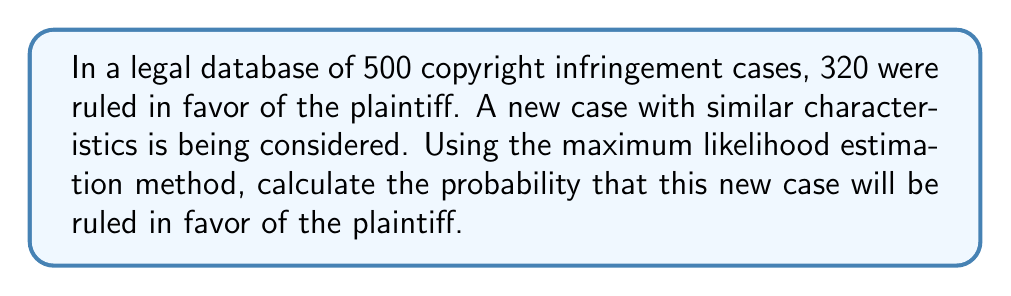Solve this math problem. To solve this inverse problem, we'll use the maximum likelihood estimation (MLE) method to estimate the probability of a ruling in favor of the plaintiff based on historical data.

Step 1: Define the probability model
Let $p$ be the probability of a ruling in favor of the plaintiff.

Step 2: Write the likelihood function
The likelihood function for a binomial distribution is:
$$L(p) = \binom{n}{k} p^k (1-p)^{n-k}$$
where $n$ is the total number of cases, and $k$ is the number of cases ruled in favor of the plaintiff.

Step 3: Simplify the likelihood function
Since we're only interested in finding the maximum, we can ignore the constant term:
$$L(p) \propto p^k (1-p)^{n-k}$$

Step 4: Take the logarithm of the likelihood function
$$\ln L(p) = k \ln p + (n-k) \ln(1-p)$$

Step 5: Find the maximum by differentiating and setting to zero
$$\frac{d}{dp} \ln L(p) = \frac{k}{p} - \frac{n-k}{1-p} = 0$$

Step 6: Solve for p
$$\frac{k}{p} = \frac{n-k}{1-p}$$
$$k(1-p) = p(n-k)$$
$$k - kp = np - kp$$
$$k = np$$
$$p = \frac{k}{n}$$

Step 7: Plug in the values
$n = 500$ (total cases)
$k = 320$ (cases ruled in favor of the plaintiff)

$$p = \frac{320}{500} = 0.64$$

Therefore, the estimated probability that the new case will be ruled in favor of the plaintiff is 0.64 or 64%.
Answer: $0.64$ or $64\%$ 